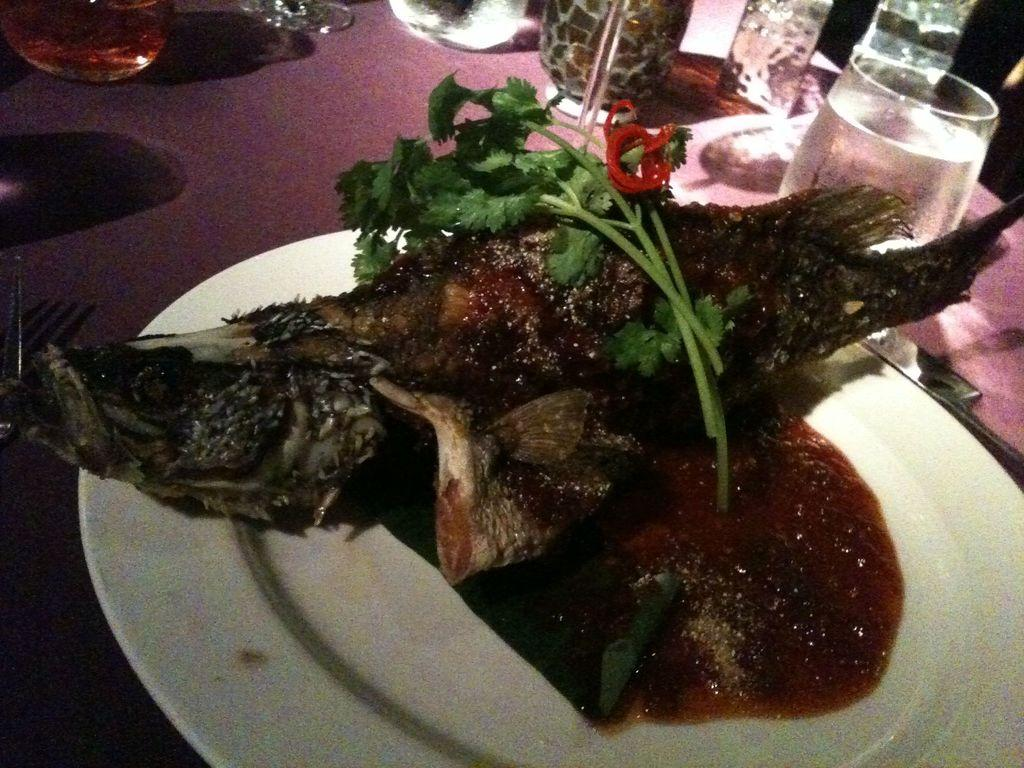What is the color of the plate that holds the food item in the image? The plate is white. What type of surface do the glasses rest on? The glasses are on a wooden surface. Where are these items located in the image? These elements are visible in the middle of the image. What caused the earthquake in the image? There is no earthquake present in the image. How many flies can be seen buzzing around the food item in the image? There are no flies visible in the image. 